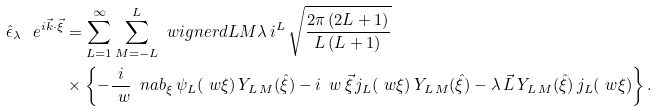<formula> <loc_0><loc_0><loc_500><loc_500>\hat { \epsilon } _ { \lambda } \, \ e ^ { i \vec { k } \cdot \vec { \xi } } & = \sum _ { L = 1 } ^ { \infty } \sum _ { M = - L } ^ { L } \ w i g n e r d { L } { M } { \lambda } \, i ^ { L } \, \sqrt { \frac { 2 \pi \, ( 2 L + 1 ) } { L \, ( L + 1 ) } } \\ & \times \left \{ - \frac { i } { \ w } \, \ n a b _ { \xi } \, \psi _ { L } ( \ w \xi ) \, Y _ { L \, M } ( \hat { \xi } ) - i \, \ w \, \vec { \xi } \, j _ { L } ( \ w \xi ) \, Y _ { L \, M } ( \hat { \xi } ) - \lambda \, \vec { L } \, Y _ { L \, M } ( \hat { \xi } ) \, j _ { L } ( \ w \xi ) \right \} .</formula> 